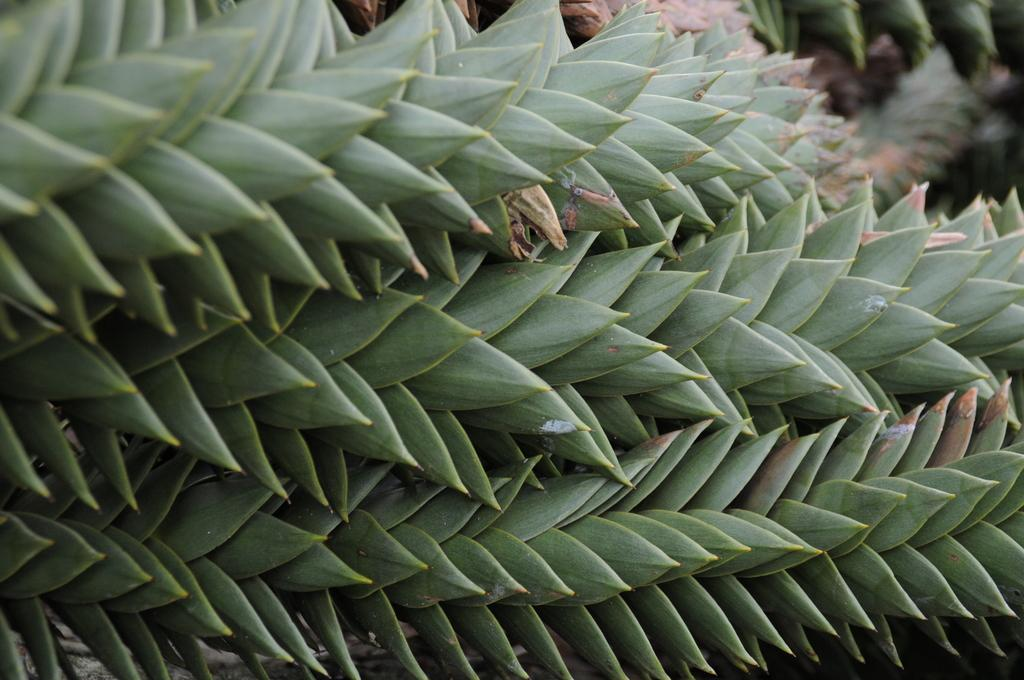What type of living organisms can be seen in the image? Plants can be seen in the image. What type of operation is being performed on the birds in the image? There are no birds present in the image, and therefore no operation is being performed on them. 